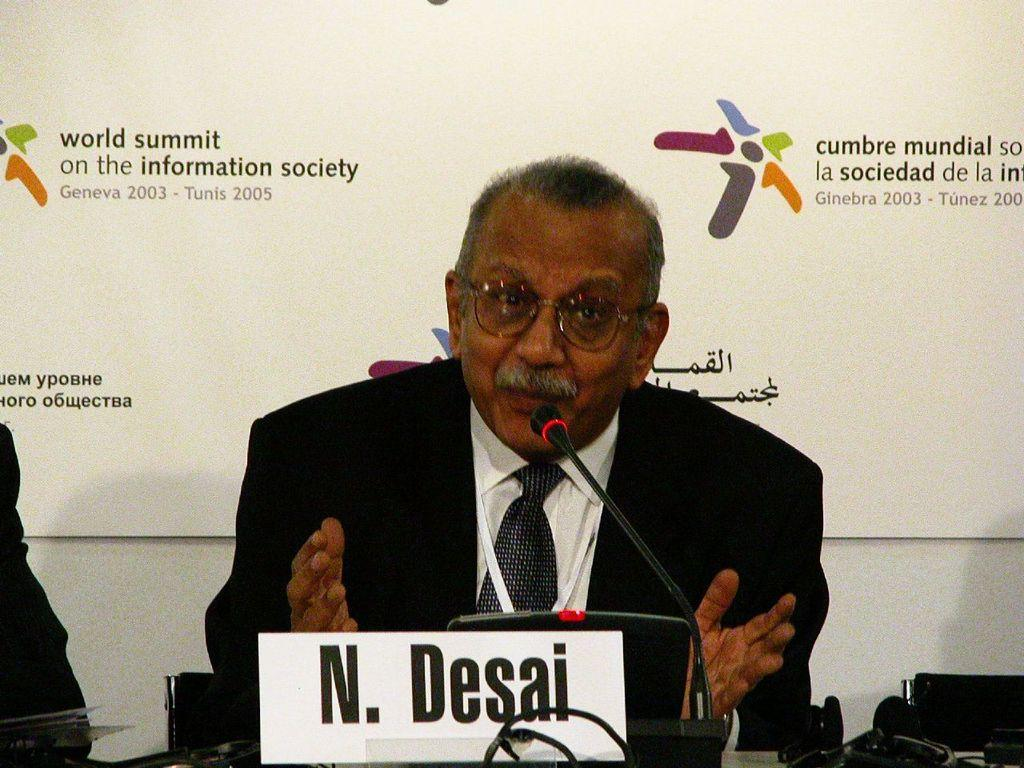Who is the main subject in the image? There is an old man in the image. What is the old man wearing? The old man is wearing a black suit and white shirt. Where is the old man sitting? The old man is sitting in front of a table. What is the old man doing in the image? The old man is talking on a mic. What can be seen behind the old man? There is a banner behind the old man. What type of celery is being served on the table in the image? There is no celery present in the image. How much money is the old man holding in the image? The image does not show the old man holding any money. 